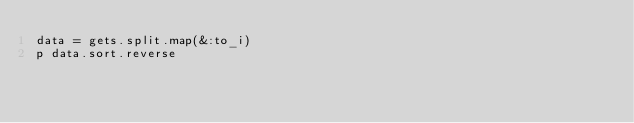Convert code to text. <code><loc_0><loc_0><loc_500><loc_500><_Ruby_>data = gets.split.map(&:to_i)
p data.sort.reverse</code> 